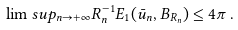<formula> <loc_0><loc_0><loc_500><loc_500>\lim s u p _ { n \to + \infty } R _ { n } ^ { - 1 } E _ { 1 } ( \bar { u } _ { n } , B _ { R _ { n } } ) \leq 4 \pi \, .</formula> 